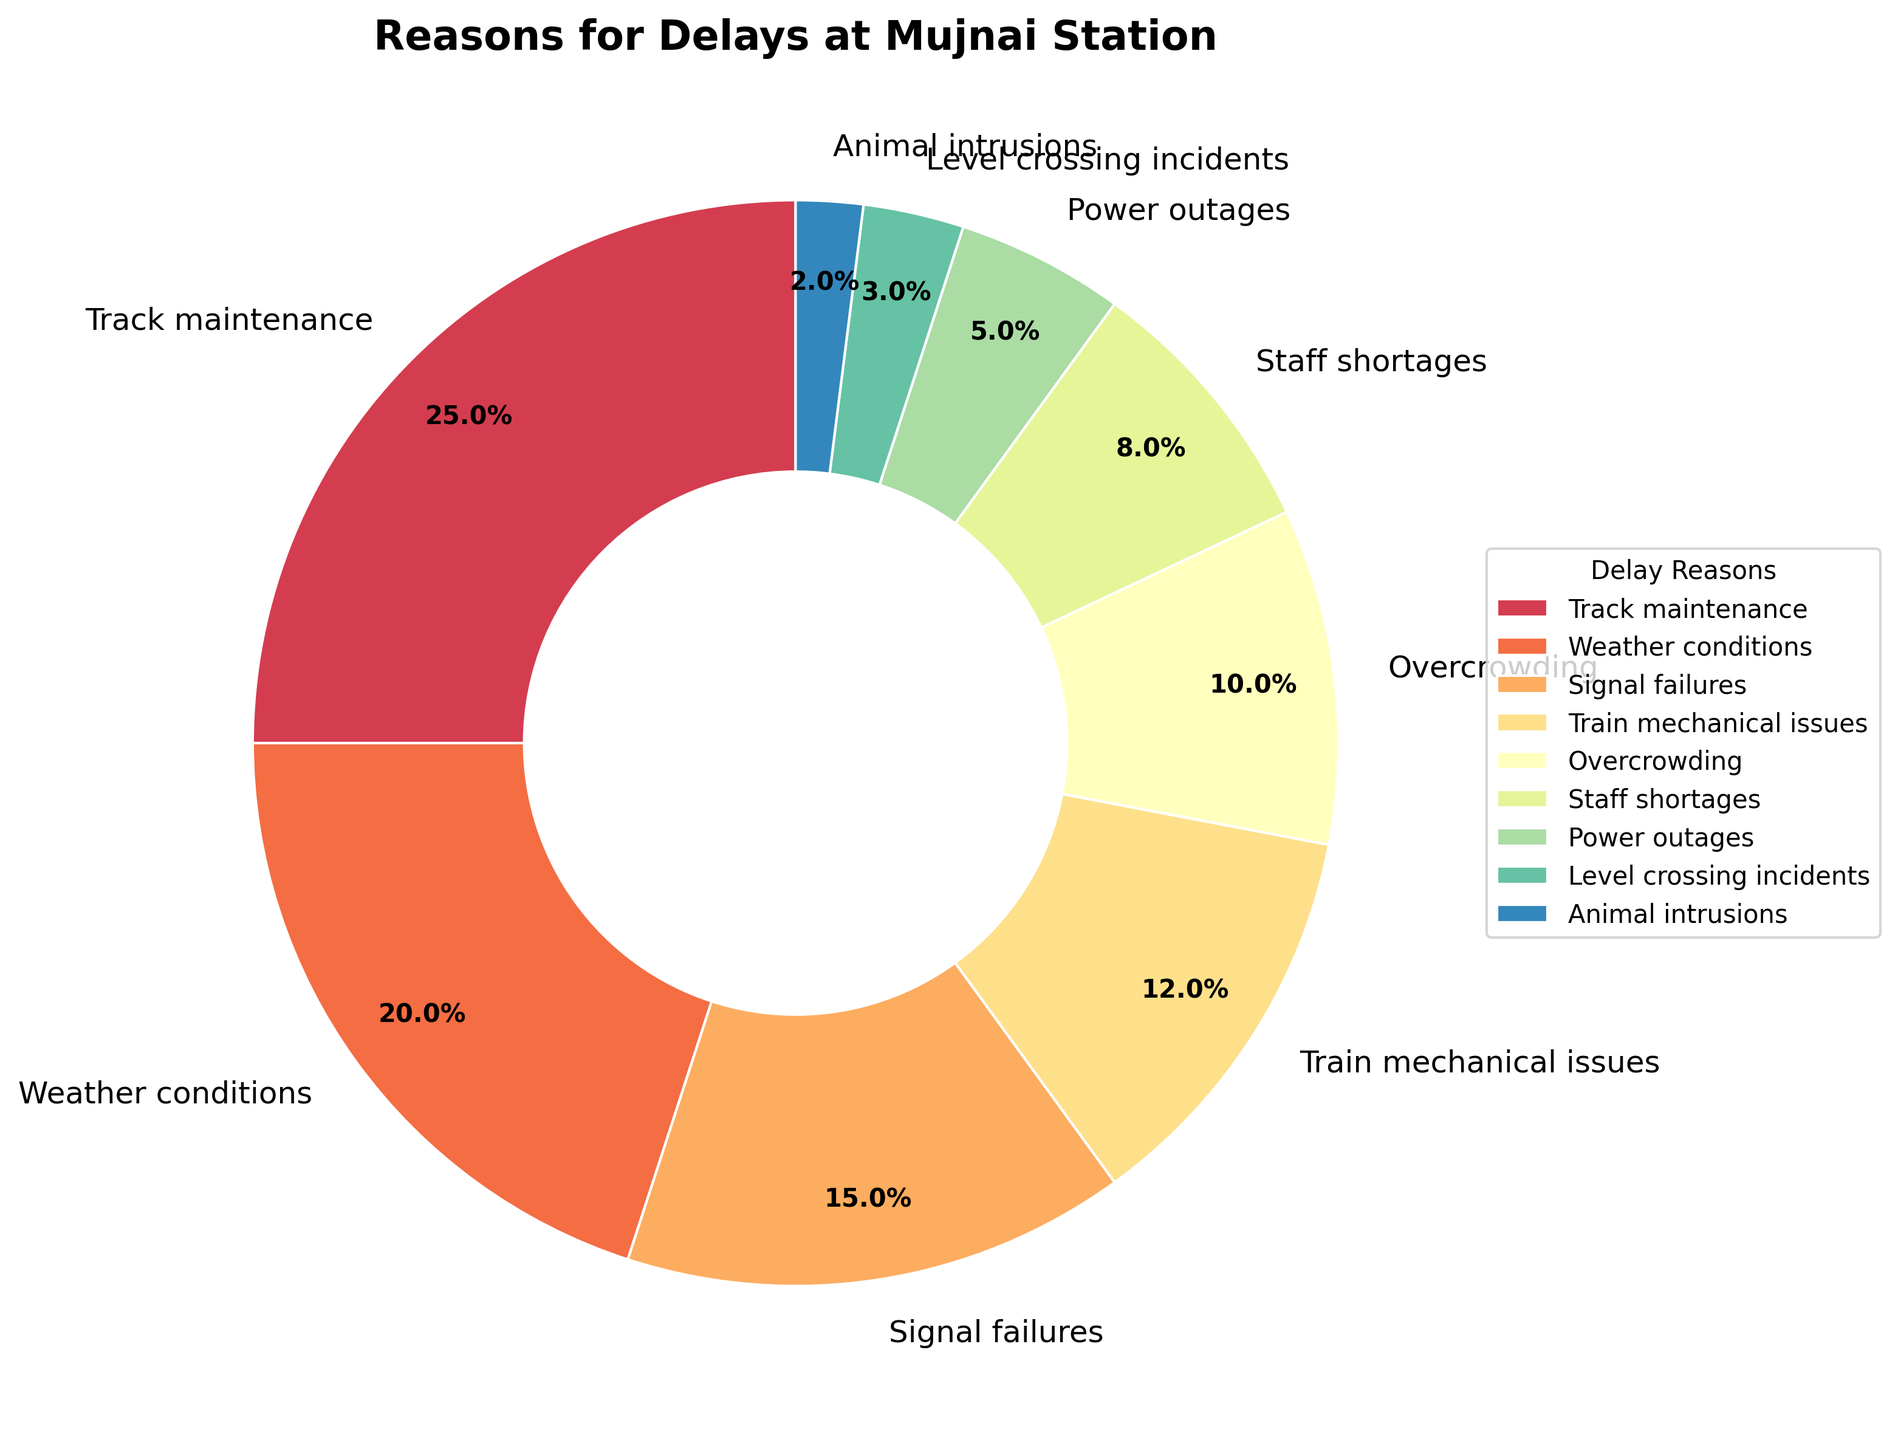Which reason contributes the most to delays at Mujnai station? According to the pie chart, the segment with the largest percentage represents "Track maintenance" at 25%.
Answer: Track maintenance What percentage of delays is due to weather conditions and signal failures combined? Adding the percentages of weather conditions (20%) and signal failures (15%) gives a total of 35%.
Answer: 35% Does overcrowding cause more delays than staff shortages? The pie chart shows overcrowding at 10% and staff shortages at 8%, indicating that overcrowding causes more delays.
Answer: Yes Which color wedge represents train mechanical issues? By looking at the colors in the pie chart legend, train mechanical issues are represented by the third-to-last wedge color from the legend.
Answer: Third-to-last wedge color How many categories cause more than 15% of the delays? The only categories with percentages greater than 15% are "Track maintenance" (25%) and "Weather conditions" (20%). So there are two categories.
Answer: 2 What is the smallest percentage cause of delays and which reason corresponds to it? The smallest wedge in the pie chart represents "Animal intrusions" with a percentage of 2%.
Answer: Animal intrusions, 2% By how much does the percentage of delays due to track maintenance exceed the percentage of delays due to train mechanical issues? The percentage for track maintenance is 25% and for train mechanical issues it is 12%. The difference is 25% - 12% = 13%.
Answer: 13% What percentage of delays is caused by factors other than the top two reasons? The top two reasons are track maintenance (25%) and weather conditions (20%), which together account for 45%. Subtracting this from 100% gives 100% - 45% = 55%.
Answer: 55% 